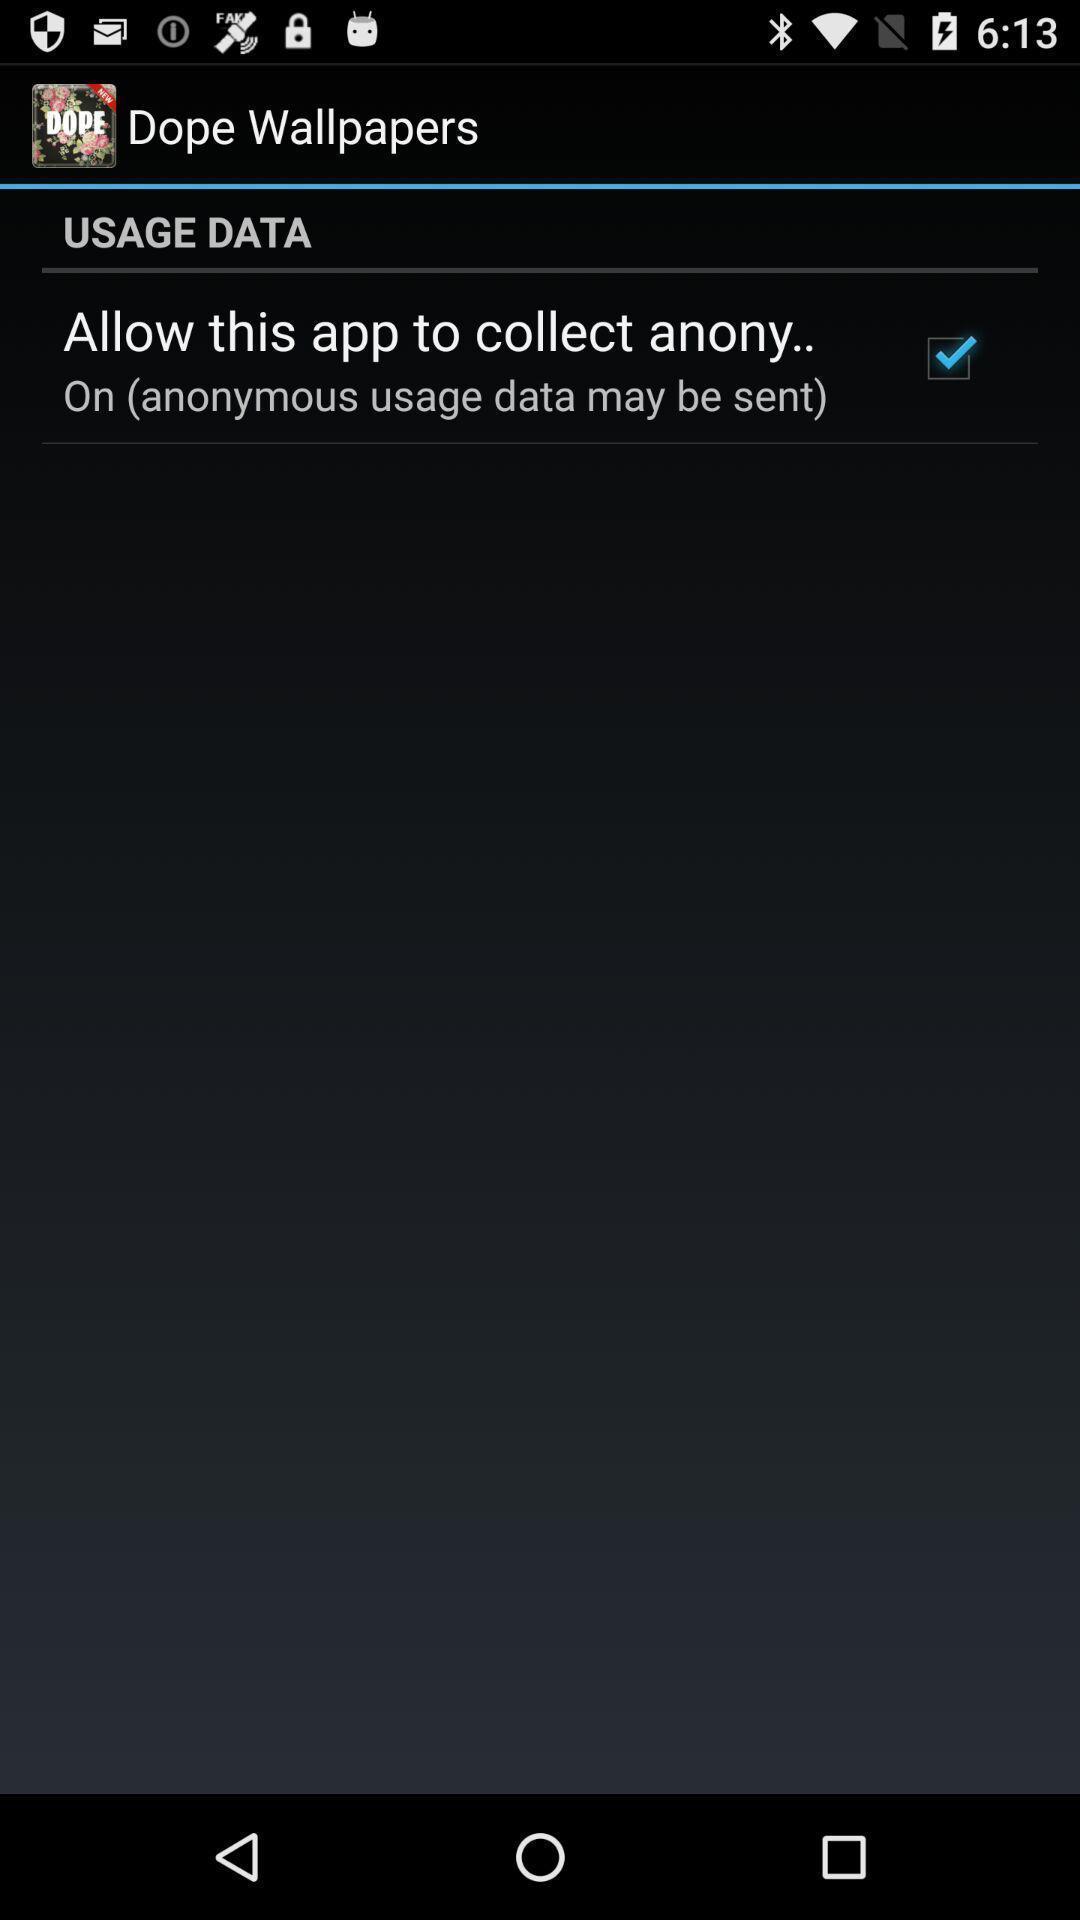Explain what's happening in this screen capture. Page showing the option with a check box. 